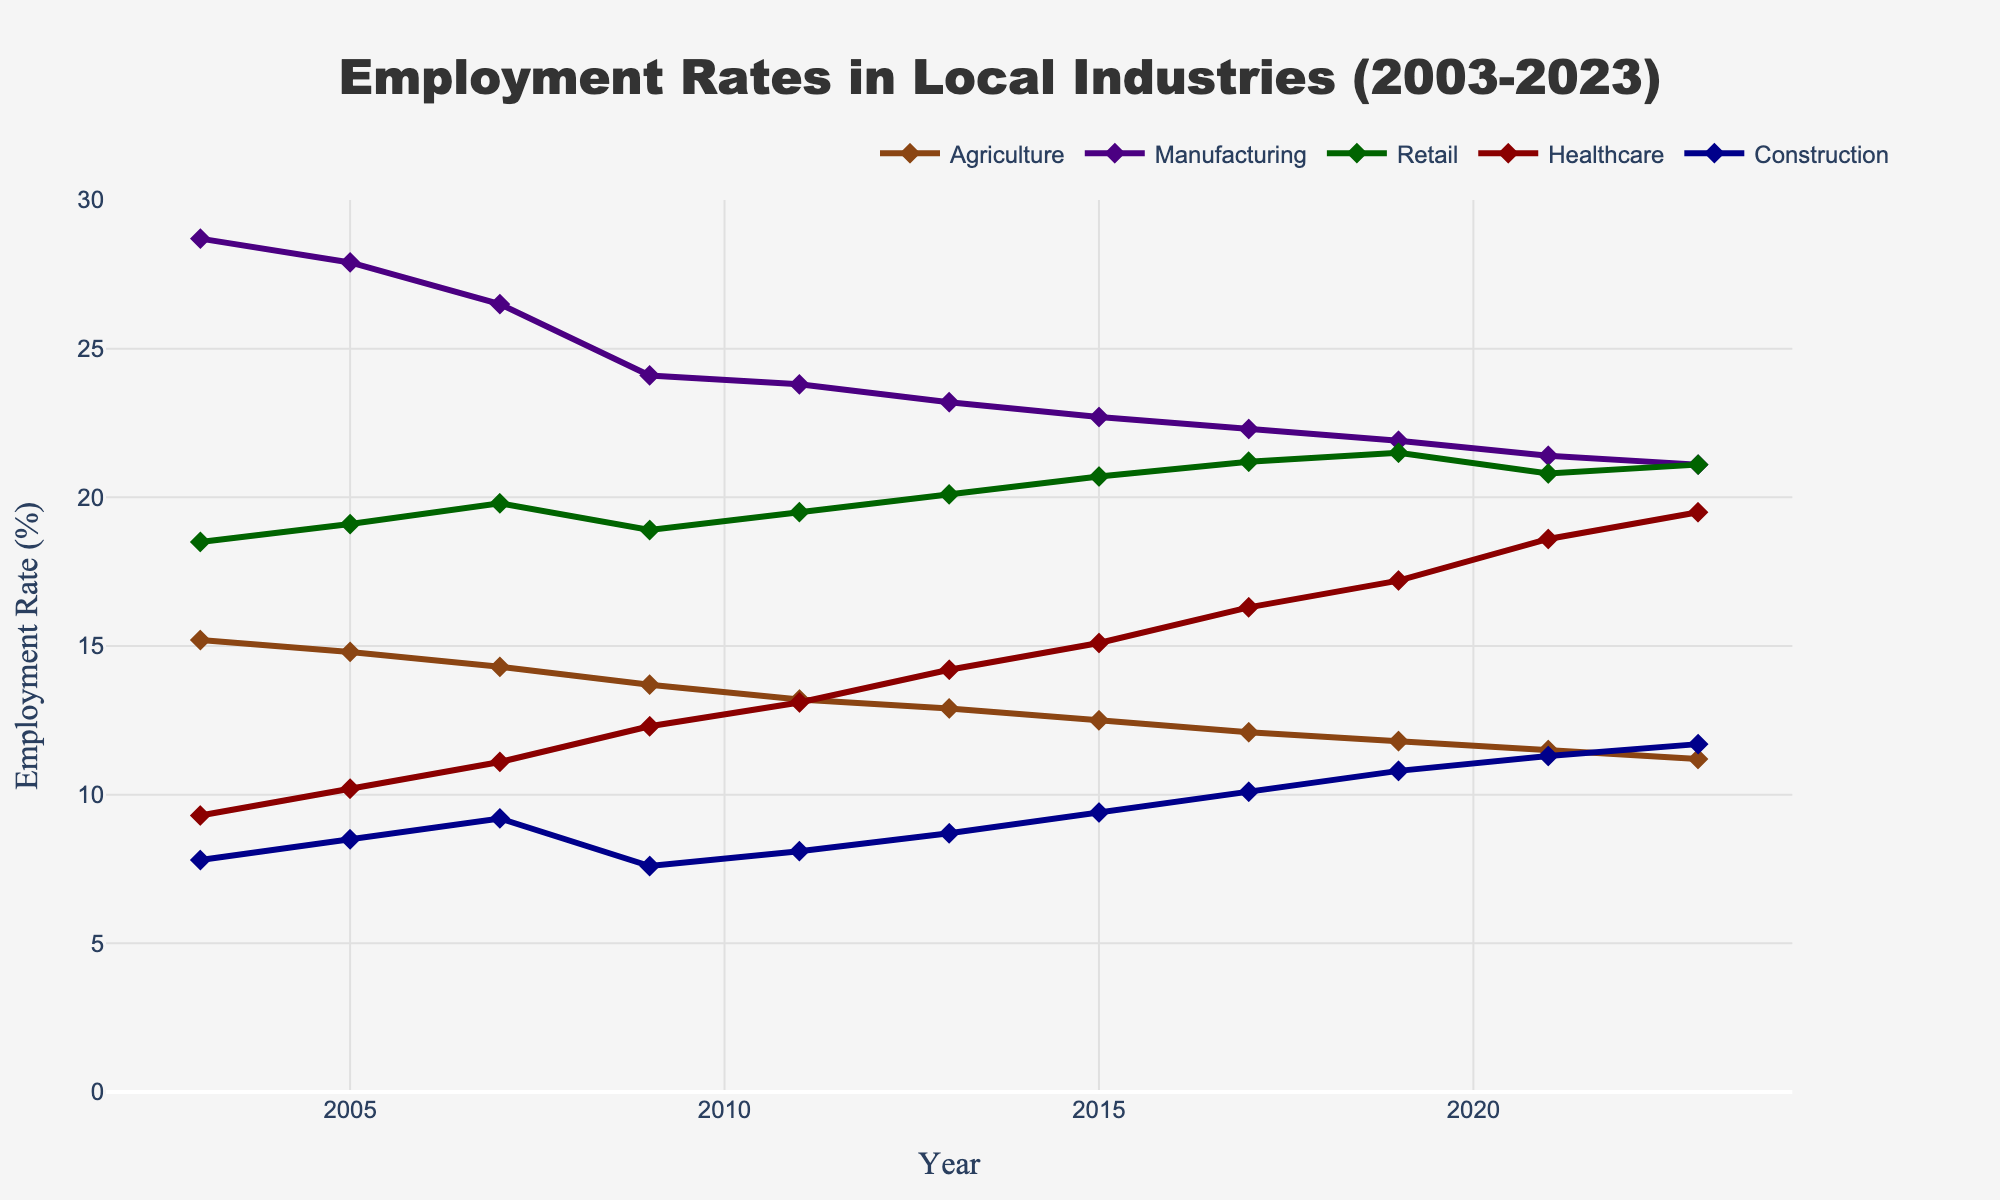What is the overall trend in the employment rate for the Healthcare industry over the past 20 years? Over the past 20 years, the employment rate in the Healthcare industry has shown a consistent upward trend. Starting from 9.3% in 2003, it has steadily increased to 19.5% by 2023.
Answer: Consistent upward trend Which industry had the highest employment rate in 2019? By looking at the values for each industry in 2019, we observe the following rates: Agriculture (11.8%), Manufacturing (21.9%), Retail (21.5%), Healthcare (17.2%), and Construction (10.8%). Thus, Manufacturing had the highest employment rate in 2019.
Answer: Manufacturing How has the employment rate in the Agriculture industry changed from 2003 to 2023? In 2003, the employment rate in Agriculture was 15.2%. By 2023, it decreased to 11.2%. The rate shows a decline of 4.0% over the 20-year period.
Answer: Decreased by 4.0% Compare the employment rates in Retail and Construction in 2021. Which one is higher, and by how much? In 2021, the employment rate for Retail was 20.8% and for Construction was 11.3%. Hence, Retail's employment rate is higher by 9.5%.
Answer: Retail is higher by 9.5% What is the sum of the employment rates in Agriculture and Construction in 2015? Looking at the 2015 data, the employment rates for Agriculture and Construction are 12.5% and 9.4% respectively. The sum is 12.5% + 9.4% = 21.9%.
Answer: 21.9% Which industry had the smallest increase in its employment rate from 2003 to 2023? To determine this, we subtract the 2003 rates from the 2023 rates for each industry: Agriculture: 15.2% to 11.2%, Manufacturing: 28.7% to 21.1%, Retail: 18.5% to 21.1%, Healthcare: 9.3% to 19.5%, Construction: 7.8% to 11.7%. The smallest increase is for Manufacturing, which actually decreased by 7.6%.
Answer: Manufacturing What's the median employment rate for Retail from 2003 to 2023? The employment rates for Retail over the years are: 18.5%, 19.1%, 19.8%, 18.9%, 19.5%, 20.1%, 20.7%, 21.2%, 21.5%, 20.8%, and 21.1%. Ordering these values, the median is the 6th value in the ordered list: 18.9, 19.1, 19.5, 19.5, 20.1, 20.7, 20.8, 21.1, 21.2, 21.5. Thus, the median is 20.1%.
Answer: 20.1% In which year did the employment rate for Healthcare surpass that of Manufacturing for the first time? By observing the change over the years, we see that Healthcare surpassed Manufacturing in 2011, when the rates were Healthcare (13.1%) and Manufacturing (23.8%). From 2013 onward, Healthcare's rates are consistently higher than those of Manufacturing.
Answer: 2011 